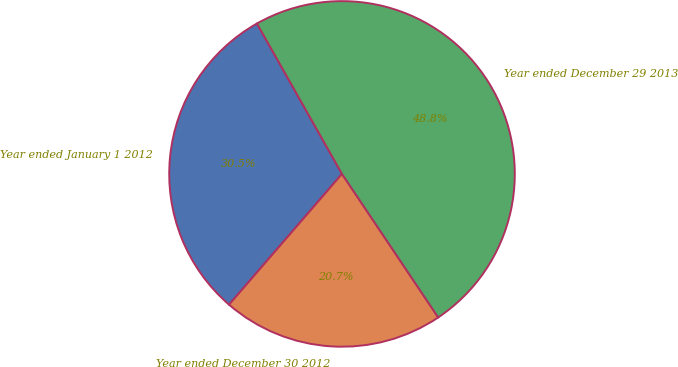Convert chart. <chart><loc_0><loc_0><loc_500><loc_500><pie_chart><fcel>Year ended January 1 2012<fcel>Year ended December 30 2012<fcel>Year ended December 29 2013<nl><fcel>30.47%<fcel>20.74%<fcel>48.79%<nl></chart> 